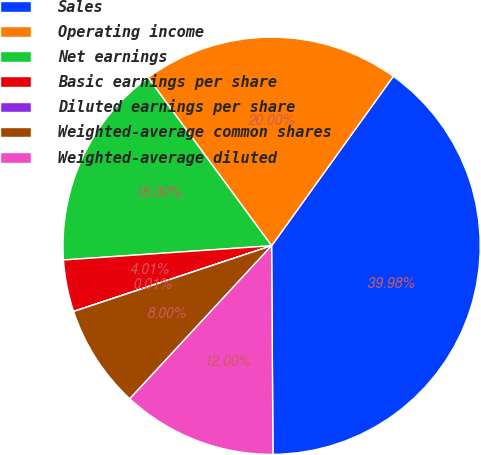Convert chart. <chart><loc_0><loc_0><loc_500><loc_500><pie_chart><fcel>Sales<fcel>Operating income<fcel>Net earnings<fcel>Basic earnings per share<fcel>Diluted earnings per share<fcel>Weighted-average common shares<fcel>Weighted-average diluted<nl><fcel>39.98%<fcel>20.0%<fcel>16.0%<fcel>4.01%<fcel>0.01%<fcel>8.0%<fcel>12.0%<nl></chart> 